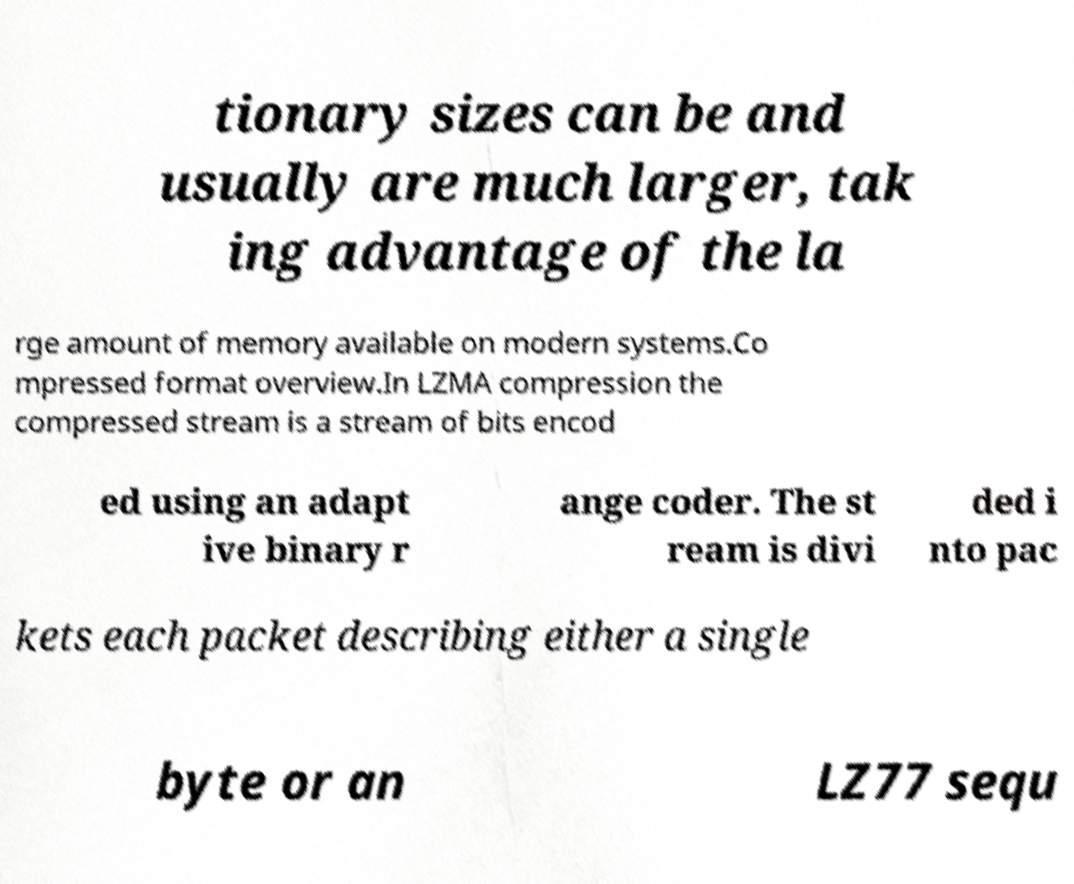There's text embedded in this image that I need extracted. Can you transcribe it verbatim? tionary sizes can be and usually are much larger, tak ing advantage of the la rge amount of memory available on modern systems.Co mpressed format overview.In LZMA compression the compressed stream is a stream of bits encod ed using an adapt ive binary r ange coder. The st ream is divi ded i nto pac kets each packet describing either a single byte or an LZ77 sequ 